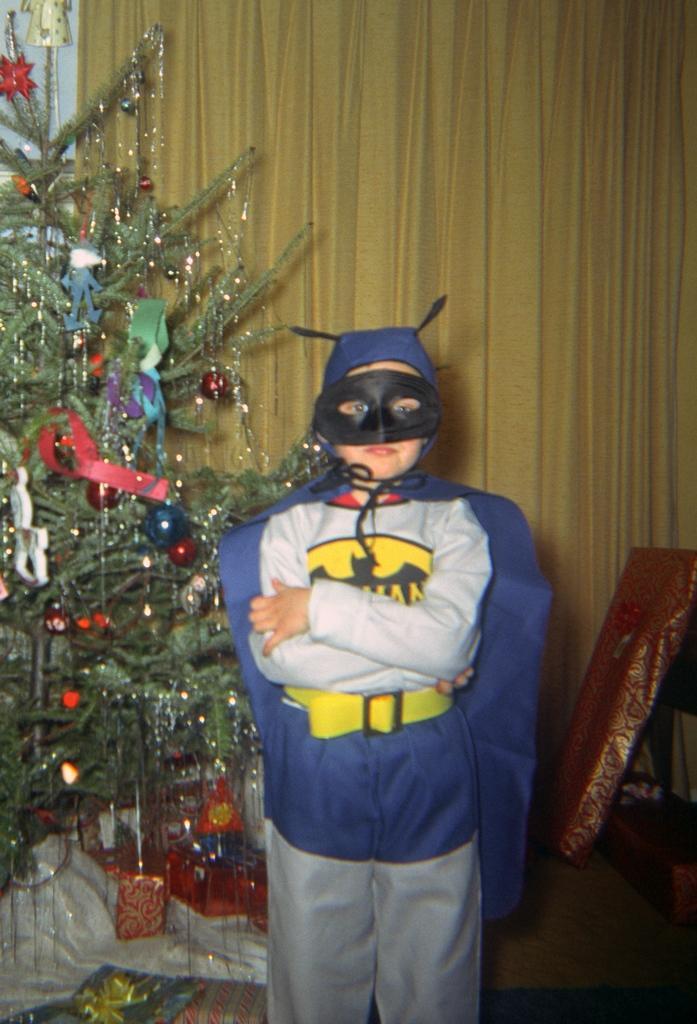Describe this image in one or two sentences. In this image there is a kid standing. He is wearing a costume. Beside him there is a Christmas tree. Left bottom there are gift boxes on the floor. Right side there are gift boxes on the wooden furniture. Background there is a wall. There are different decorative items hanging on the Christmas tree. 